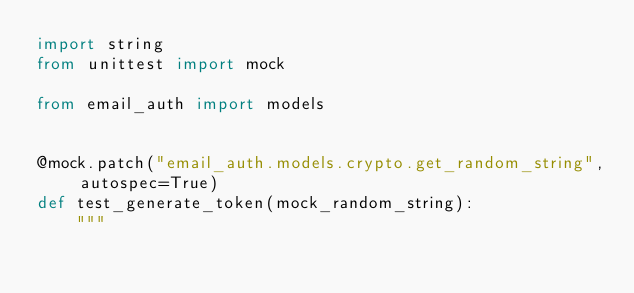Convert code to text. <code><loc_0><loc_0><loc_500><loc_500><_Python_>import string
from unittest import mock

from email_auth import models


@mock.patch("email_auth.models.crypto.get_random_string", autospec=True)
def test_generate_token(mock_random_string):
    """</code> 